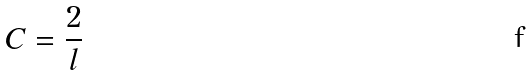<formula> <loc_0><loc_0><loc_500><loc_500>C = \frac { 2 } { l }</formula> 